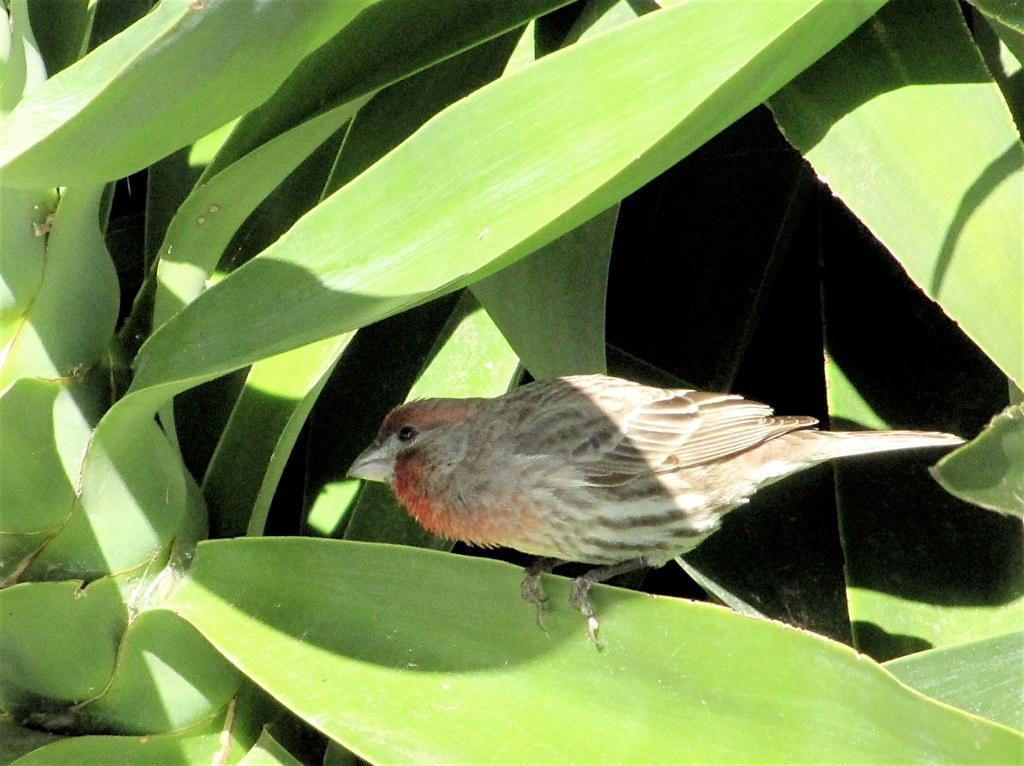What type of animal is present in the image? There is a bird in the image. Where is the bird located? The bird is on a leaf of a plant. What type of nation is depicted in the image? There is no nation depicted in the image; it features a bird on a leaf of a plant. What type of milk is being consumed by the bird in the image? There is no milk present in the image; it features a bird on a leaf of a plant. 